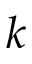<formula> <loc_0><loc_0><loc_500><loc_500>k</formula> 